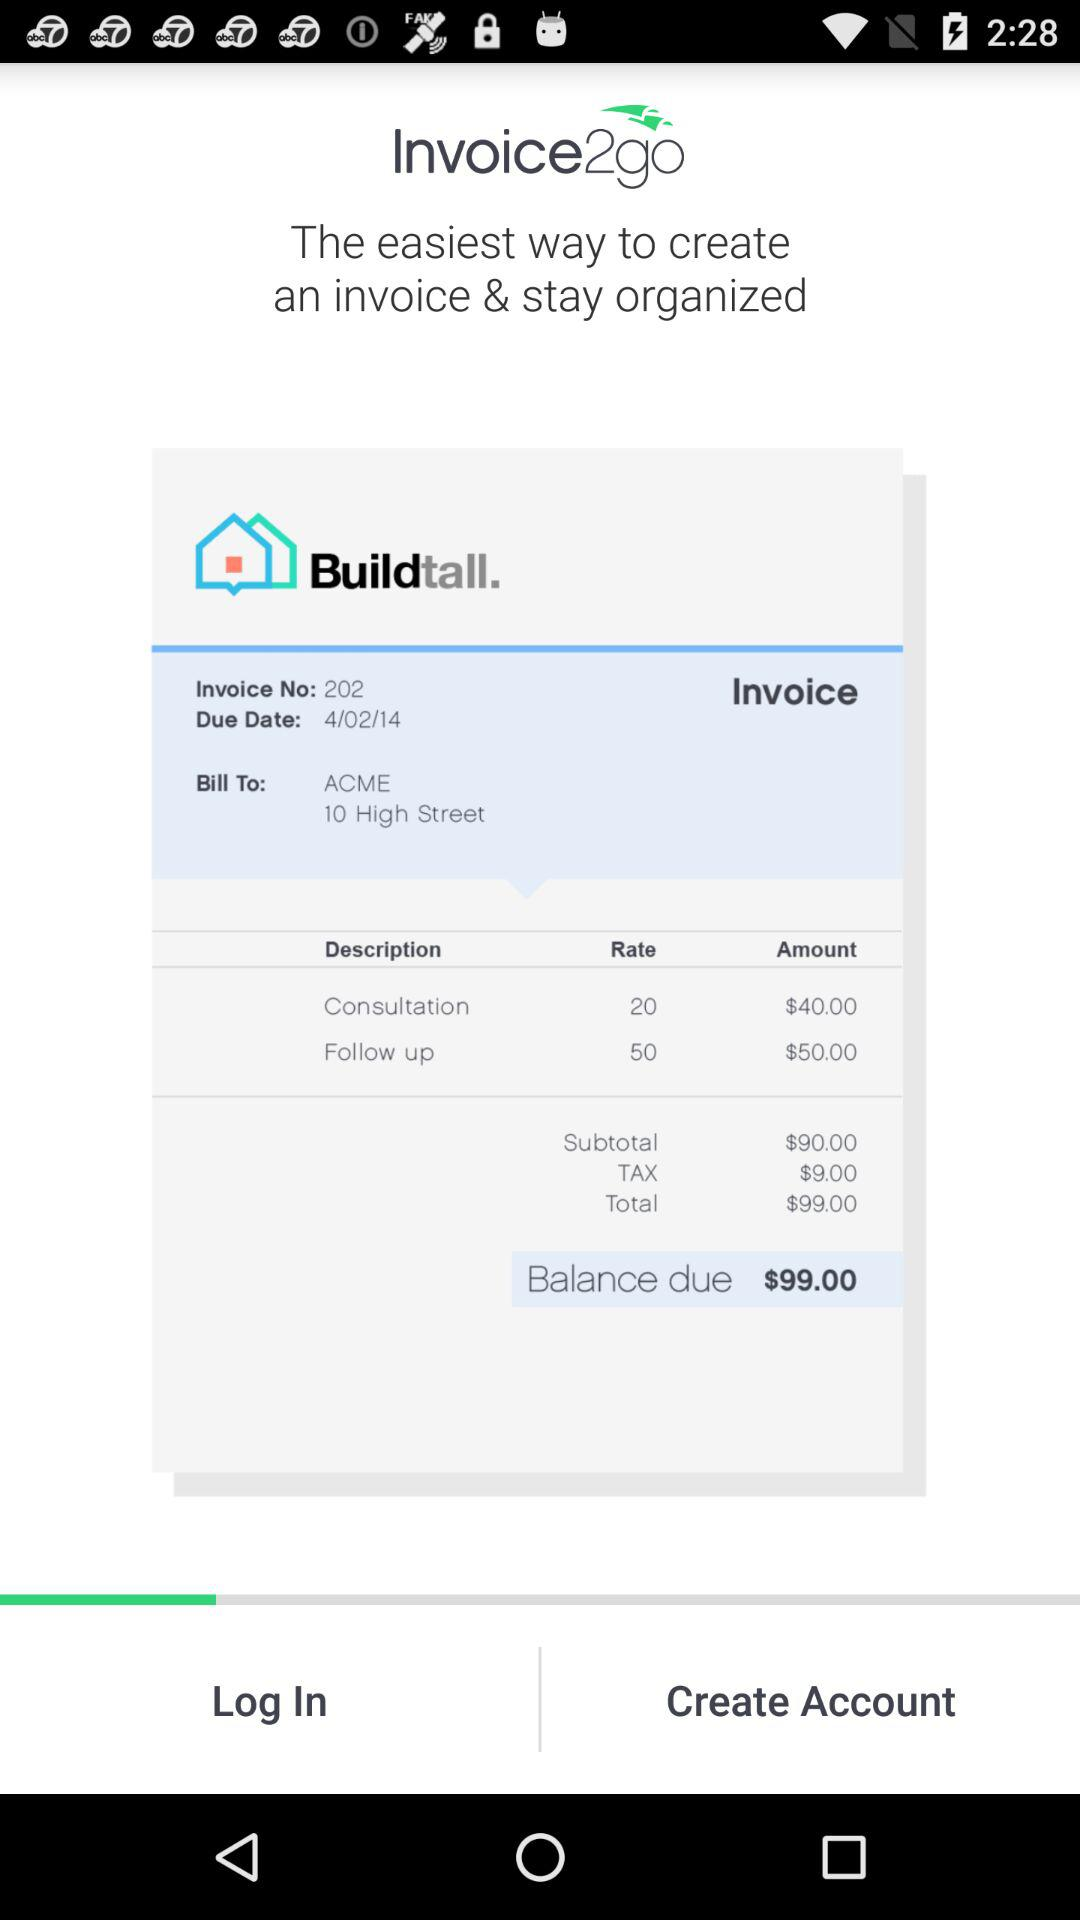What is the balance due? The balance due is $99.00. 